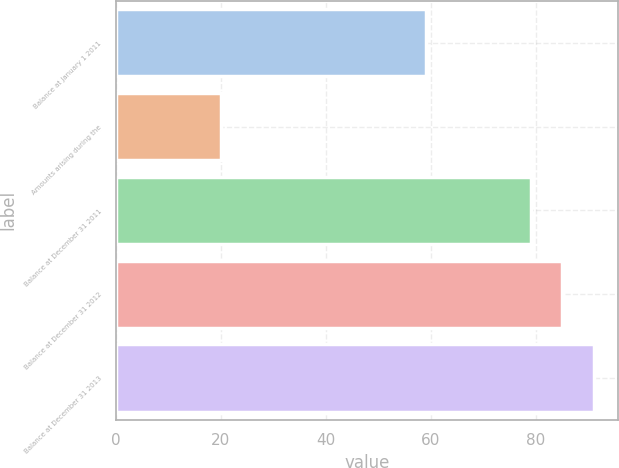Convert chart to OTSL. <chart><loc_0><loc_0><loc_500><loc_500><bar_chart><fcel>Balance at January 1 2011<fcel>Amounts arising during the<fcel>Balance at December 31 2011<fcel>Balance at December 31 2012<fcel>Balance at December 31 2013<nl><fcel>59<fcel>20<fcel>79<fcel>85<fcel>91<nl></chart> 